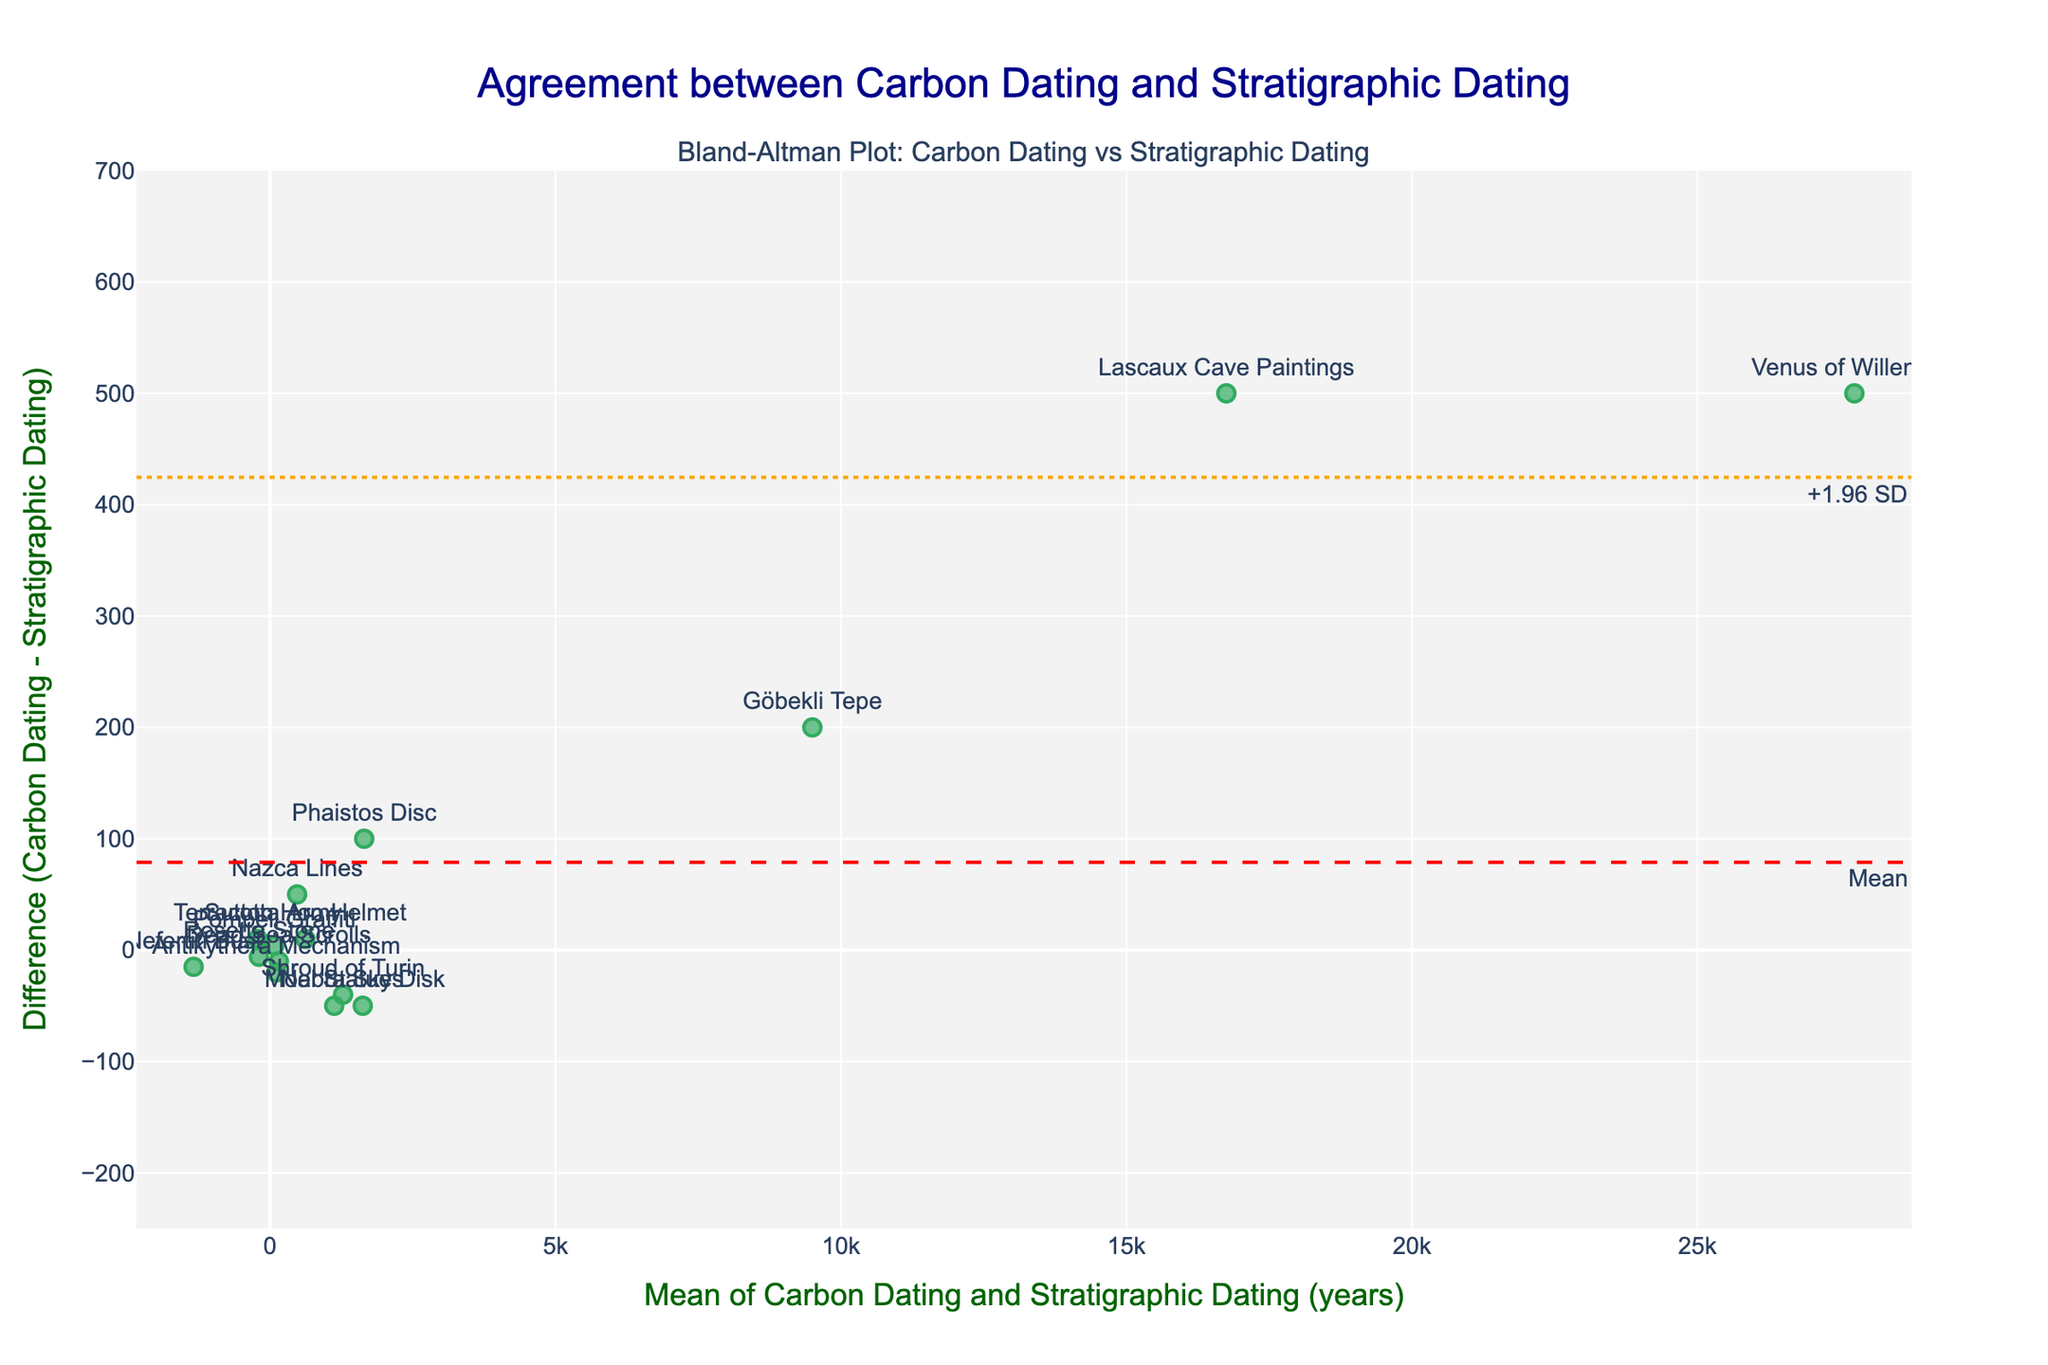What is the title of the Bland-Altman plot? The title of the plot is located at the top of the figure. It clearly states the purpose of the plot.
Answer: Agreement between Carbon Dating and Stratigraphic Dating What is the y-axis title of the plot? The title for the y-axis is mentioned on the left side of the plot. This title indicates what the y-axis measures.
Answer: Difference (Carbon Dating - Stratigraphic Dating) Which artifact has the largest positive difference between Carbon Dating and Stratigraphic Dating? To find this, look at the points above 0 on the y-axis and identify the one with the highest value.
Answer: Venus of Willendorf What is the mean difference (the red dashed line) in the plot? The mean difference is represented by the red dashed line annotated with the text "Mean."
Answer: Close to zero What is the range of the x-axis in the Bland-Altman plot? Check the x-axis at the bottom of the plot to find the minimum and maximum values it covers.
Answer: Approximately -5000 to 30000 Which artifact is represented by the data point nearest to the origin (0,0)? Identify the point that is closest to the (0,0) coordinate on the plot and check the annotation.
Answer: Sutton Hoo Helmet Are there any artifacts whose difference in dating methods are beyond the limits of agreement? The limits of agreement are marked by the orange dotted lines. Check if any points lie outside these boundaries.
Answer: No Which artifact has a Carbon Dating value that is older than its Stratigraphic Dating value, represented by a point below the zero difference line? Identify artifacts below the zero difference line, indicating Carbon Dating is older than Stratigraphic Dating, and check their labels.
Answer: Terracotta Army What is the approximate value of the upper limit of agreement (+1.96 SD) line? The upper limit of agreement is indicated by the top orange dotted line with the annotation "+1.96 SD."
Answer: Around 500 By how many years does the Carbon Dating of Nefertiti Bust differ from its Stratigraphic Dating? Locate the Nefertiti Bust data point's y-value, which represents the difference between Carbon Dating and Stratigraphic Dating for this artifact.
Answer: -15 (-1345 - (-1330)) 